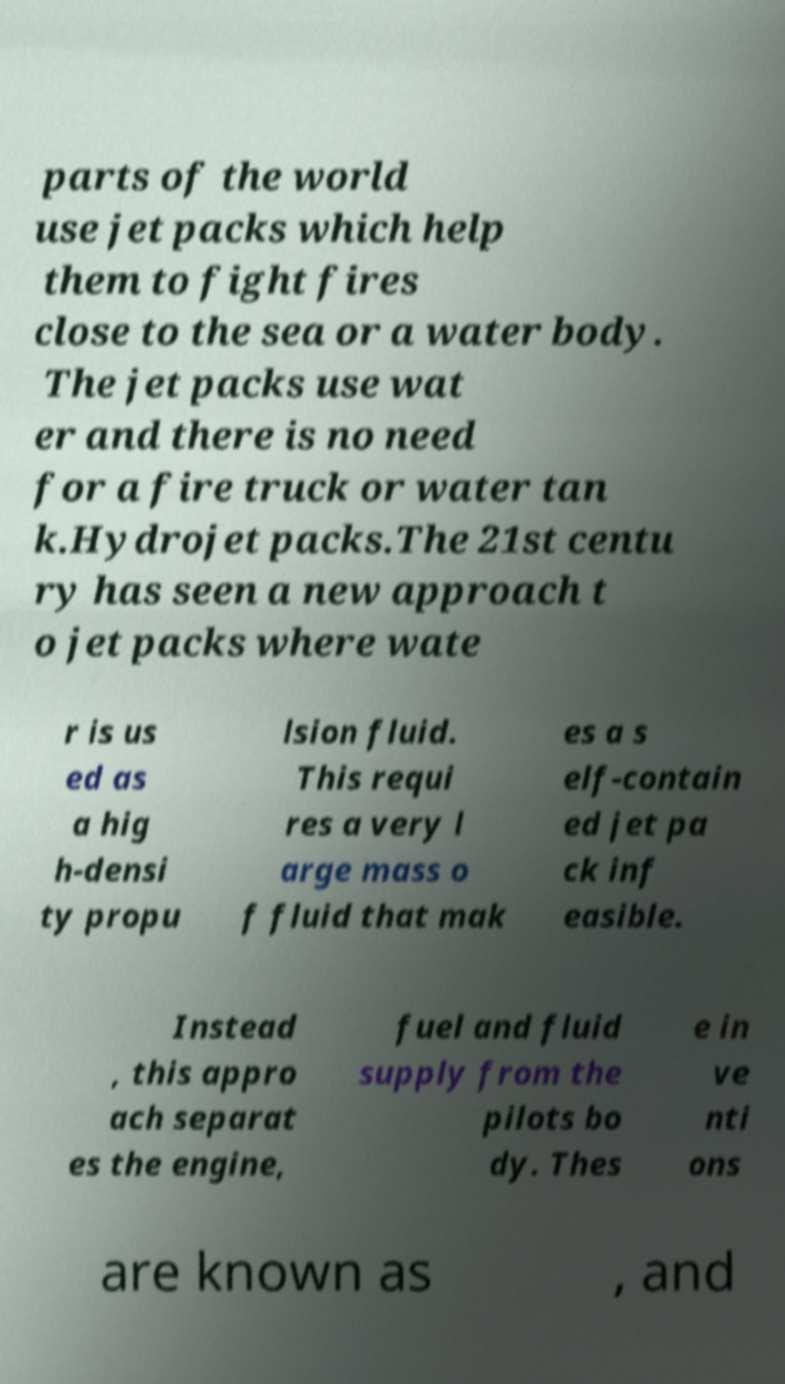I need the written content from this picture converted into text. Can you do that? parts of the world use jet packs which help them to fight fires close to the sea or a water body. The jet packs use wat er and there is no need for a fire truck or water tan k.Hydrojet packs.The 21st centu ry has seen a new approach t o jet packs where wate r is us ed as a hig h-densi ty propu lsion fluid. This requi res a very l arge mass o f fluid that mak es a s elf-contain ed jet pa ck inf easible. Instead , this appro ach separat es the engine, fuel and fluid supply from the pilots bo dy. Thes e in ve nti ons are known as , and 